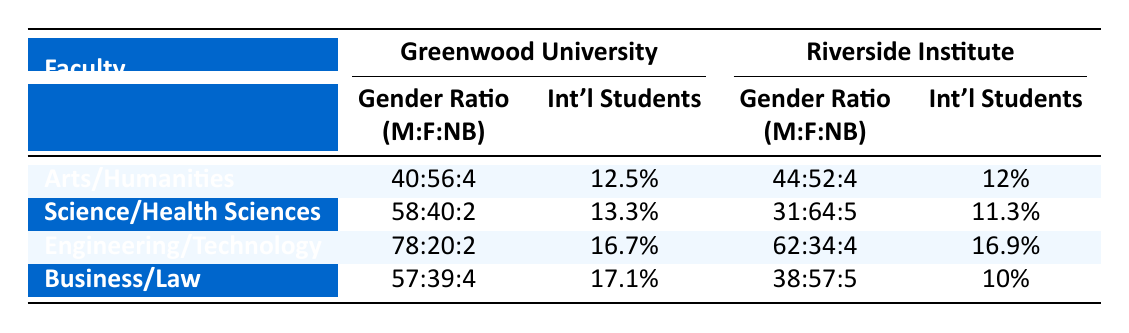What is the gender ratio of students in the Faculty of Arts at Greenwood University? The gender distribution for the Faculty of Arts shows 320 male, 450 female, and 30 non-binary students. The ratio is represented as male:female:non-binary, which simplifies to 40:56:4.
Answer: 40:56:4 How many international students are enrolled in the Faculty of Science at Greenwood University? The demographics for the Faculty of Science indicate that there are 80 international students enrolled.
Answer: 80 Which faculty at Riverside Institute has the highest percentage of international students? To find the percentage for each faculty, divide the number of international students by the total number of students and multiply by 100. The percentages are: Humanities (12%), Health Sciences (11.25%), Law (10%), Technology (16.92%). The highest percentage is from the Faculty of Technology.
Answer: Technology Is the gender ratio in the Faculty of Health Sciences at Riverside Institute more balanced than in the Faculty of Engineering at Greenwood University? The gender ratio in Health Sciences is 31:64:5 which indicates a more balanced distribution between male and female than Engineering's 78:20:2. Hence, Health Sciences has a more balanced gender ratio since it has almost equal representation of males and females.
Answer: Yes What is the total number of students across all faculties at Greenwood University? The total number of students is calculated by adding total students from each faculty: Arts (800) + Science (600) + Engineering (900) + Business (700) = 3000.
Answer: 3000 What is the average number of international students per faculty at Riverside Institute? To find the average number of international students, add the number of international students across all faculties: Humanities (60) + Health Sciences (90) + Law (40) + Technology (110) = 300. Then divide by the number of faculties (4). So, 300/4 = 75.
Answer: 75 Is the proportion of non-binary students higher in the Faculty of Law compared to the Faculty of Arts? The non-binary proportion in Law is 20 out of 400 total students (5%) while in Arts it's 30 out of 800 (3.75%). Hence, the proportion of non-binary students is higher in Law compared to Arts.
Answer: Yes Which faculty has the highest total student enrollment among both universities? By comparing total enrollments: Arts (800), Science (600), Engineering (900), Business (700) for Greenwood University and Humanities (500), Health Sciences (800), Law (400), Technology (650) for Riverside Institute, Engineering at Greenwood University has the highest enrollment at 900 students.
Answer: Engineering How does the percentage of international students in the Faculty of Business compare to that in the Faculty of Health Sciences? The percentage in Business is calculated as (120/700)*100 which equals approximately 17.14%, whereas in Health Sciences it is (90/800)*100 which equals 11.25%. Therefore, the Faculty of Business has a higher percentage of international students compared to Health Sciences.
Answer: Business has a higher percentage 